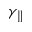<formula> <loc_0><loc_0><loc_500><loc_500>\gamma _ { \| }</formula> 